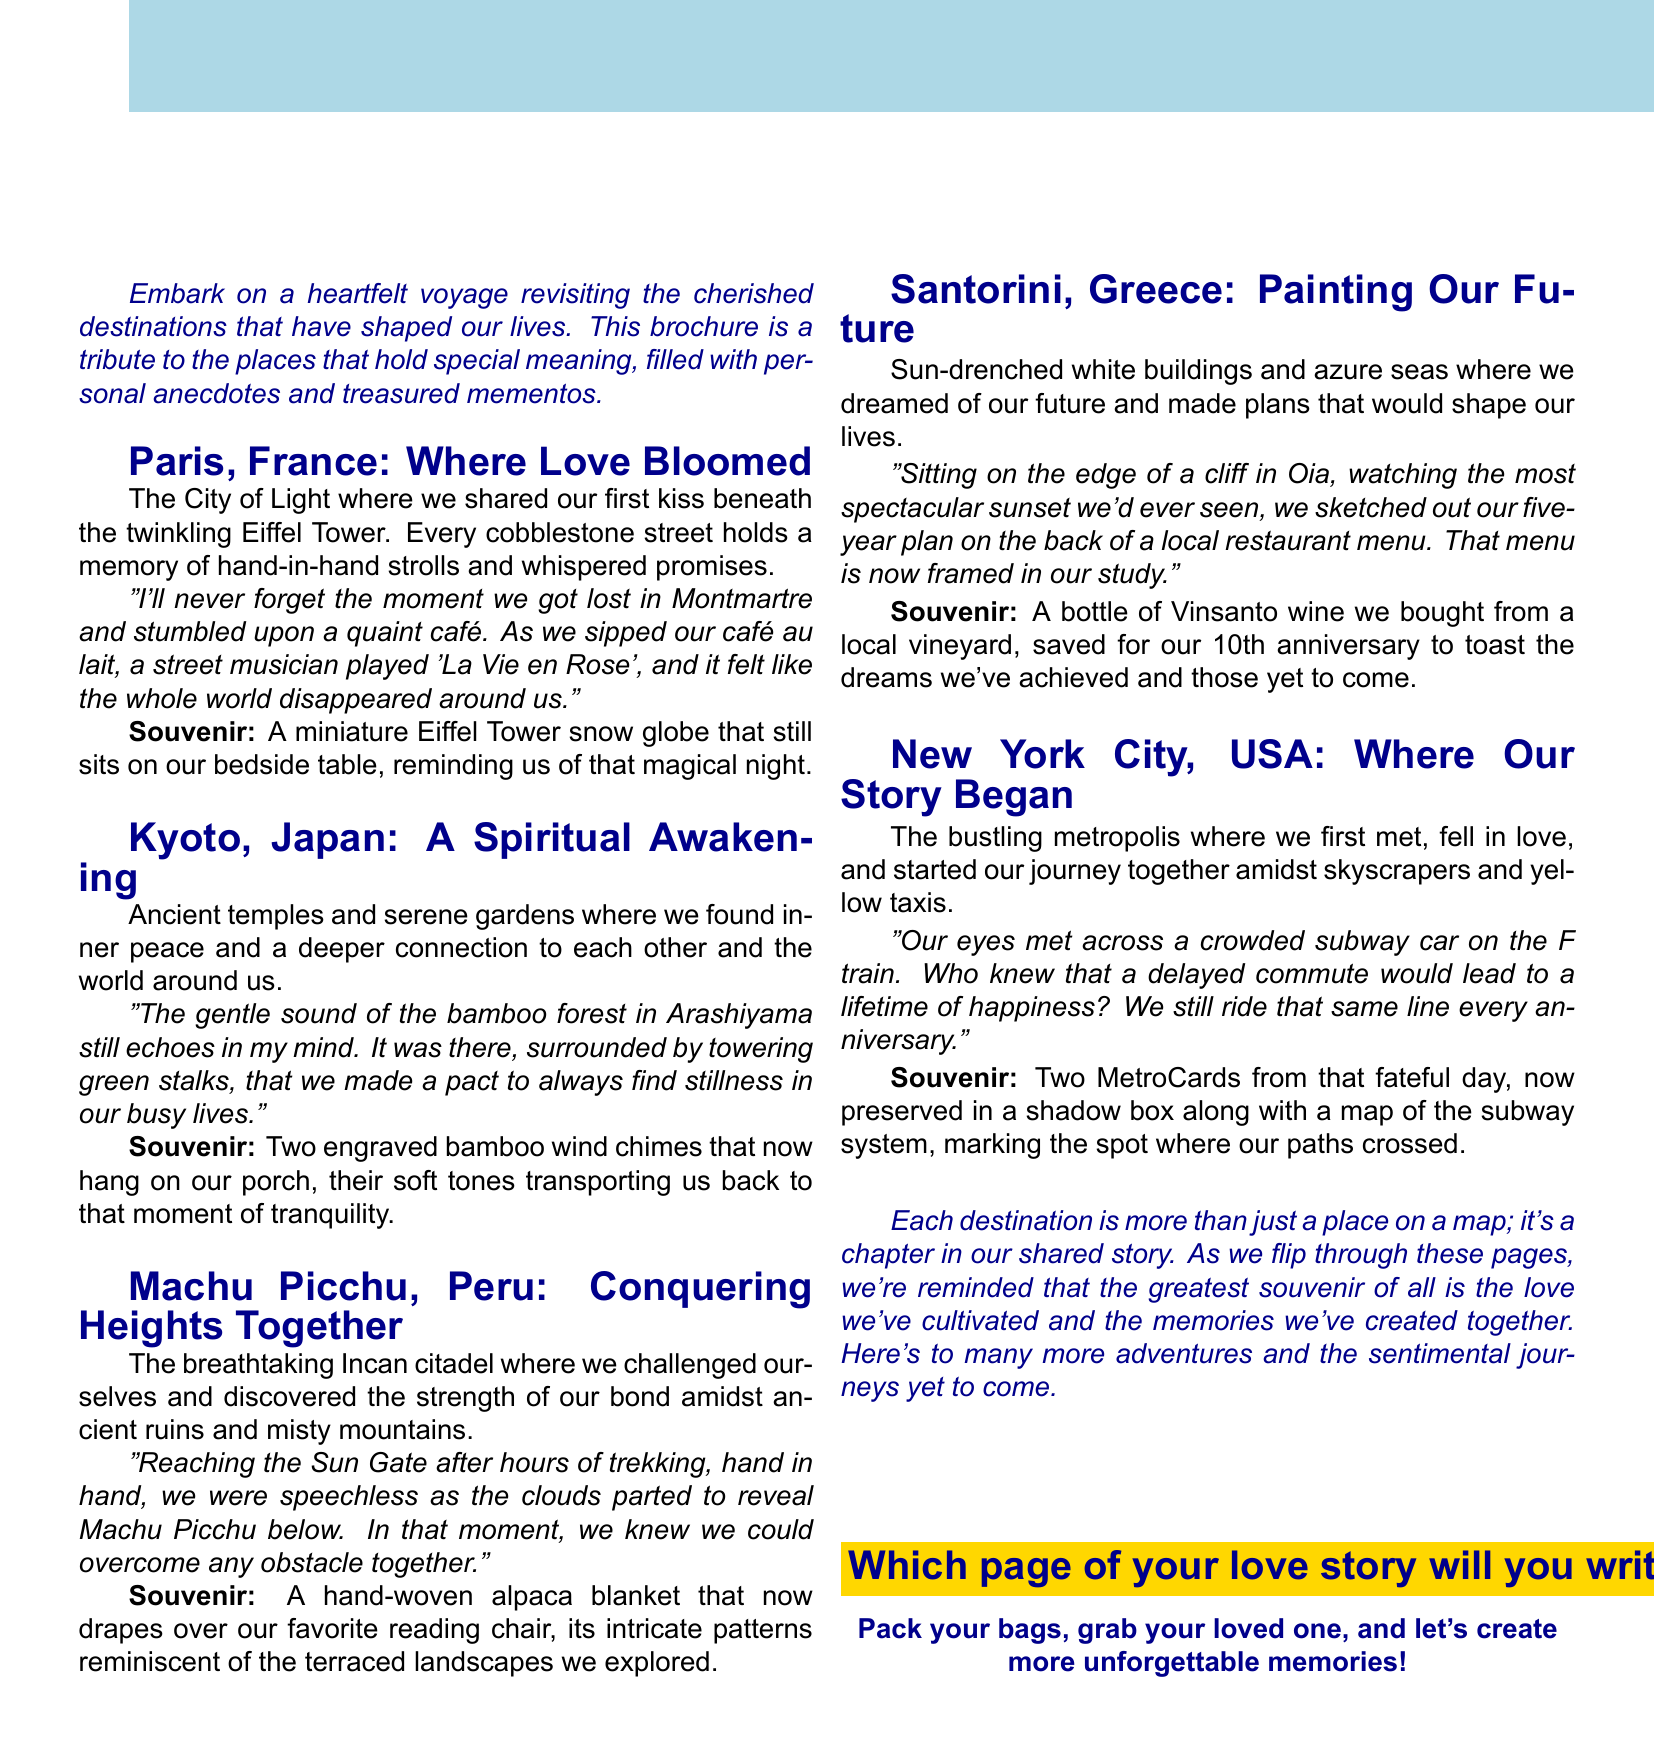What is the title of the brochure? The title is stated at the top of the document, summarizing the theme of the brochure.
Answer: Memories in Motion: A Sentimental Journey Through Time How many destinations are highlighted in the brochure? The document lists a total of five unique destinations that are discussed in detail.
Answer: Five What souvenir is associated with Paris, France? The souvenir from Paris is mentioned in the section about that destination, reflecting a cherished memory.
Answer: A miniature Eiffel Tower snow globe What personal anecdote is shared about Kyoto, Japan? The anecdote recounted is connected to an experience in the bamboo forest, illustrating a moment of connection.
Answer: The gentle sound of the bamboo forest in Arashiyama still echoes in my mind Which city is referred to as "Where Our Story Began"? This phrase is specifically used to describe New York City, emphasizing its significance in the relationship.
Answer: New York City What is the call to action at the end of the brochure? The call to action invites readers to embark on their own journey, encouraging the creation of new memories.
Answer: Pack your bags, grab your loved one, and let's create more unforgettable memories! What is the tagline for Santorini, Greece? The tagline for Santorini encapsulates the essence of the memories made there, focusing on future aspirations.
Answer: Painting Our Future What type of wine is saved for their 10th anniversary? This detail is included in the description of the Santorini experience, highlighting a special toast planned for a milestone.
Answer: Vinsanto wine 